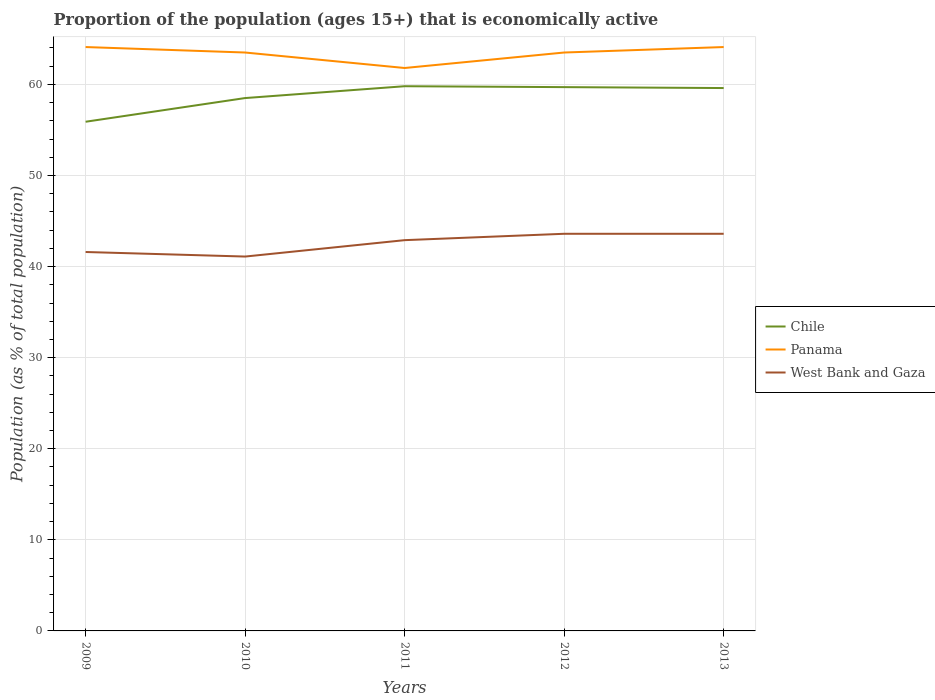How many different coloured lines are there?
Give a very brief answer. 3. Across all years, what is the maximum proportion of the population that is economically active in Panama?
Your response must be concise. 61.8. What is the total proportion of the population that is economically active in West Bank and Gaza in the graph?
Offer a very short reply. -0.7. What is the difference between the highest and the second highest proportion of the population that is economically active in Panama?
Ensure brevity in your answer.  2.3. What is the difference between the highest and the lowest proportion of the population that is economically active in Chile?
Offer a terse response. 3. How many years are there in the graph?
Offer a very short reply. 5. What is the difference between two consecutive major ticks on the Y-axis?
Give a very brief answer. 10. Are the values on the major ticks of Y-axis written in scientific E-notation?
Your answer should be very brief. No. How many legend labels are there?
Provide a short and direct response. 3. How are the legend labels stacked?
Your response must be concise. Vertical. What is the title of the graph?
Keep it short and to the point. Proportion of the population (ages 15+) that is economically active. What is the label or title of the Y-axis?
Give a very brief answer. Population (as % of total population). What is the Population (as % of total population) in Chile in 2009?
Provide a succinct answer. 55.9. What is the Population (as % of total population) of Panama in 2009?
Offer a terse response. 64.1. What is the Population (as % of total population) in West Bank and Gaza in 2009?
Your response must be concise. 41.6. What is the Population (as % of total population) in Chile in 2010?
Keep it short and to the point. 58.5. What is the Population (as % of total population) in Panama in 2010?
Ensure brevity in your answer.  63.5. What is the Population (as % of total population) of West Bank and Gaza in 2010?
Provide a short and direct response. 41.1. What is the Population (as % of total population) of Chile in 2011?
Your response must be concise. 59.8. What is the Population (as % of total population) in Panama in 2011?
Offer a very short reply. 61.8. What is the Population (as % of total population) of West Bank and Gaza in 2011?
Your answer should be compact. 42.9. What is the Population (as % of total population) of Chile in 2012?
Your answer should be very brief. 59.7. What is the Population (as % of total population) in Panama in 2012?
Make the answer very short. 63.5. What is the Population (as % of total population) in West Bank and Gaza in 2012?
Keep it short and to the point. 43.6. What is the Population (as % of total population) in Chile in 2013?
Your answer should be very brief. 59.6. What is the Population (as % of total population) in Panama in 2013?
Make the answer very short. 64.1. What is the Population (as % of total population) of West Bank and Gaza in 2013?
Provide a short and direct response. 43.6. Across all years, what is the maximum Population (as % of total population) in Chile?
Ensure brevity in your answer.  59.8. Across all years, what is the maximum Population (as % of total population) of Panama?
Give a very brief answer. 64.1. Across all years, what is the maximum Population (as % of total population) of West Bank and Gaza?
Your response must be concise. 43.6. Across all years, what is the minimum Population (as % of total population) in Chile?
Give a very brief answer. 55.9. Across all years, what is the minimum Population (as % of total population) in Panama?
Make the answer very short. 61.8. Across all years, what is the minimum Population (as % of total population) in West Bank and Gaza?
Make the answer very short. 41.1. What is the total Population (as % of total population) in Chile in the graph?
Make the answer very short. 293.5. What is the total Population (as % of total population) of Panama in the graph?
Make the answer very short. 317. What is the total Population (as % of total population) in West Bank and Gaza in the graph?
Your answer should be compact. 212.8. What is the difference between the Population (as % of total population) in Panama in 2009 and that in 2010?
Make the answer very short. 0.6. What is the difference between the Population (as % of total population) in West Bank and Gaza in 2009 and that in 2010?
Your answer should be very brief. 0.5. What is the difference between the Population (as % of total population) in Chile in 2009 and that in 2011?
Your response must be concise. -3.9. What is the difference between the Population (as % of total population) in Panama in 2009 and that in 2011?
Your answer should be very brief. 2.3. What is the difference between the Population (as % of total population) in West Bank and Gaza in 2009 and that in 2011?
Your answer should be compact. -1.3. What is the difference between the Population (as % of total population) of Chile in 2009 and that in 2012?
Your response must be concise. -3.8. What is the difference between the Population (as % of total population) in Panama in 2009 and that in 2012?
Give a very brief answer. 0.6. What is the difference between the Population (as % of total population) of Chile in 2009 and that in 2013?
Offer a terse response. -3.7. What is the difference between the Population (as % of total population) of West Bank and Gaza in 2009 and that in 2013?
Give a very brief answer. -2. What is the difference between the Population (as % of total population) of Panama in 2010 and that in 2011?
Provide a succinct answer. 1.7. What is the difference between the Population (as % of total population) of West Bank and Gaza in 2010 and that in 2011?
Give a very brief answer. -1.8. What is the difference between the Population (as % of total population) in West Bank and Gaza in 2010 and that in 2012?
Provide a short and direct response. -2.5. What is the difference between the Population (as % of total population) in Chile in 2010 and that in 2013?
Your answer should be very brief. -1.1. What is the difference between the Population (as % of total population) of Panama in 2010 and that in 2013?
Give a very brief answer. -0.6. What is the difference between the Population (as % of total population) of Chile in 2011 and that in 2012?
Provide a short and direct response. 0.1. What is the difference between the Population (as % of total population) in West Bank and Gaza in 2011 and that in 2012?
Provide a succinct answer. -0.7. What is the difference between the Population (as % of total population) of Chile in 2012 and that in 2013?
Provide a short and direct response. 0.1. What is the difference between the Population (as % of total population) in Chile in 2009 and the Population (as % of total population) in Panama in 2010?
Offer a terse response. -7.6. What is the difference between the Population (as % of total population) of Chile in 2009 and the Population (as % of total population) of West Bank and Gaza in 2011?
Provide a short and direct response. 13. What is the difference between the Population (as % of total population) in Panama in 2009 and the Population (as % of total population) in West Bank and Gaza in 2011?
Ensure brevity in your answer.  21.2. What is the difference between the Population (as % of total population) in Chile in 2009 and the Population (as % of total population) in Panama in 2012?
Your answer should be very brief. -7.6. What is the difference between the Population (as % of total population) in Panama in 2009 and the Population (as % of total population) in West Bank and Gaza in 2012?
Your response must be concise. 20.5. What is the difference between the Population (as % of total population) in Chile in 2009 and the Population (as % of total population) in Panama in 2013?
Offer a very short reply. -8.2. What is the difference between the Population (as % of total population) in Panama in 2009 and the Population (as % of total population) in West Bank and Gaza in 2013?
Provide a short and direct response. 20.5. What is the difference between the Population (as % of total population) of Chile in 2010 and the Population (as % of total population) of West Bank and Gaza in 2011?
Your answer should be very brief. 15.6. What is the difference between the Population (as % of total population) of Panama in 2010 and the Population (as % of total population) of West Bank and Gaza in 2011?
Keep it short and to the point. 20.6. What is the difference between the Population (as % of total population) in Chile in 2010 and the Population (as % of total population) in Panama in 2012?
Provide a short and direct response. -5. What is the difference between the Population (as % of total population) of Panama in 2010 and the Population (as % of total population) of West Bank and Gaza in 2012?
Your answer should be compact. 19.9. What is the difference between the Population (as % of total population) in Chile in 2010 and the Population (as % of total population) in West Bank and Gaza in 2013?
Keep it short and to the point. 14.9. What is the difference between the Population (as % of total population) in Panama in 2010 and the Population (as % of total population) in West Bank and Gaza in 2013?
Provide a succinct answer. 19.9. What is the difference between the Population (as % of total population) in Chile in 2011 and the Population (as % of total population) in Panama in 2012?
Make the answer very short. -3.7. What is the difference between the Population (as % of total population) in Chile in 2011 and the Population (as % of total population) in West Bank and Gaza in 2012?
Make the answer very short. 16.2. What is the difference between the Population (as % of total population) of Chile in 2011 and the Population (as % of total population) of Panama in 2013?
Your response must be concise. -4.3. What is the difference between the Population (as % of total population) in Chile in 2011 and the Population (as % of total population) in West Bank and Gaza in 2013?
Your answer should be compact. 16.2. What is the difference between the Population (as % of total population) of Panama in 2011 and the Population (as % of total population) of West Bank and Gaza in 2013?
Offer a terse response. 18.2. What is the difference between the Population (as % of total population) of Chile in 2012 and the Population (as % of total population) of West Bank and Gaza in 2013?
Your answer should be compact. 16.1. What is the difference between the Population (as % of total population) in Panama in 2012 and the Population (as % of total population) in West Bank and Gaza in 2013?
Provide a short and direct response. 19.9. What is the average Population (as % of total population) in Chile per year?
Offer a terse response. 58.7. What is the average Population (as % of total population) of Panama per year?
Ensure brevity in your answer.  63.4. What is the average Population (as % of total population) of West Bank and Gaza per year?
Provide a succinct answer. 42.56. In the year 2010, what is the difference between the Population (as % of total population) in Chile and Population (as % of total population) in Panama?
Offer a very short reply. -5. In the year 2010, what is the difference between the Population (as % of total population) of Chile and Population (as % of total population) of West Bank and Gaza?
Provide a succinct answer. 17.4. In the year 2010, what is the difference between the Population (as % of total population) in Panama and Population (as % of total population) in West Bank and Gaza?
Give a very brief answer. 22.4. In the year 2012, what is the difference between the Population (as % of total population) in Chile and Population (as % of total population) in Panama?
Give a very brief answer. -3.8. In the year 2012, what is the difference between the Population (as % of total population) in Panama and Population (as % of total population) in West Bank and Gaza?
Make the answer very short. 19.9. In the year 2013, what is the difference between the Population (as % of total population) in Chile and Population (as % of total population) in Panama?
Offer a very short reply. -4.5. What is the ratio of the Population (as % of total population) of Chile in 2009 to that in 2010?
Your answer should be very brief. 0.96. What is the ratio of the Population (as % of total population) in Panama in 2009 to that in 2010?
Your answer should be compact. 1.01. What is the ratio of the Population (as % of total population) of West Bank and Gaza in 2009 to that in 2010?
Give a very brief answer. 1.01. What is the ratio of the Population (as % of total population) in Chile in 2009 to that in 2011?
Provide a succinct answer. 0.93. What is the ratio of the Population (as % of total population) of Panama in 2009 to that in 2011?
Provide a short and direct response. 1.04. What is the ratio of the Population (as % of total population) in West Bank and Gaza in 2009 to that in 2011?
Provide a succinct answer. 0.97. What is the ratio of the Population (as % of total population) in Chile in 2009 to that in 2012?
Keep it short and to the point. 0.94. What is the ratio of the Population (as % of total population) in Panama in 2009 to that in 2012?
Your answer should be compact. 1.01. What is the ratio of the Population (as % of total population) in West Bank and Gaza in 2009 to that in 2012?
Your answer should be compact. 0.95. What is the ratio of the Population (as % of total population) in Chile in 2009 to that in 2013?
Your answer should be very brief. 0.94. What is the ratio of the Population (as % of total population) of Panama in 2009 to that in 2013?
Give a very brief answer. 1. What is the ratio of the Population (as % of total population) in West Bank and Gaza in 2009 to that in 2013?
Keep it short and to the point. 0.95. What is the ratio of the Population (as % of total population) of Chile in 2010 to that in 2011?
Ensure brevity in your answer.  0.98. What is the ratio of the Population (as % of total population) in Panama in 2010 to that in 2011?
Ensure brevity in your answer.  1.03. What is the ratio of the Population (as % of total population) of West Bank and Gaza in 2010 to that in 2011?
Your response must be concise. 0.96. What is the ratio of the Population (as % of total population) of Chile in 2010 to that in 2012?
Ensure brevity in your answer.  0.98. What is the ratio of the Population (as % of total population) in Panama in 2010 to that in 2012?
Your answer should be compact. 1. What is the ratio of the Population (as % of total population) in West Bank and Gaza in 2010 to that in 2012?
Provide a short and direct response. 0.94. What is the ratio of the Population (as % of total population) of Chile in 2010 to that in 2013?
Your answer should be compact. 0.98. What is the ratio of the Population (as % of total population) of Panama in 2010 to that in 2013?
Give a very brief answer. 0.99. What is the ratio of the Population (as % of total population) in West Bank and Gaza in 2010 to that in 2013?
Keep it short and to the point. 0.94. What is the ratio of the Population (as % of total population) of Chile in 2011 to that in 2012?
Keep it short and to the point. 1. What is the ratio of the Population (as % of total population) of Panama in 2011 to that in 2012?
Offer a very short reply. 0.97. What is the ratio of the Population (as % of total population) of West Bank and Gaza in 2011 to that in 2012?
Your answer should be compact. 0.98. What is the ratio of the Population (as % of total population) in Chile in 2011 to that in 2013?
Provide a short and direct response. 1. What is the ratio of the Population (as % of total population) in Panama in 2011 to that in 2013?
Offer a terse response. 0.96. What is the ratio of the Population (as % of total population) of West Bank and Gaza in 2011 to that in 2013?
Provide a succinct answer. 0.98. What is the ratio of the Population (as % of total population) of Panama in 2012 to that in 2013?
Your answer should be very brief. 0.99. What is the difference between the highest and the second highest Population (as % of total population) in Panama?
Ensure brevity in your answer.  0. What is the difference between the highest and the second highest Population (as % of total population) of West Bank and Gaza?
Offer a terse response. 0. What is the difference between the highest and the lowest Population (as % of total population) in West Bank and Gaza?
Your response must be concise. 2.5. 